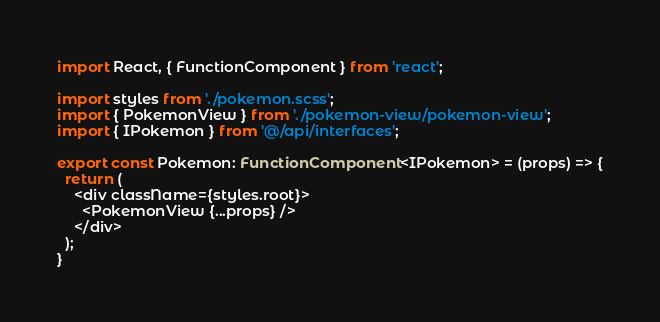<code> <loc_0><loc_0><loc_500><loc_500><_TypeScript_>import React, { FunctionComponent } from 'react';

import styles from './pokemon.scss';
import { PokemonView } from './pokemon-view/pokemon-view';
import { IPokemon } from '@/api/interfaces';

export const Pokemon: FunctionComponent<IPokemon> = (props) => {
  return (
    <div className={styles.root}>
      <PokemonView {...props} />
    </div>
  );
}
</code> 